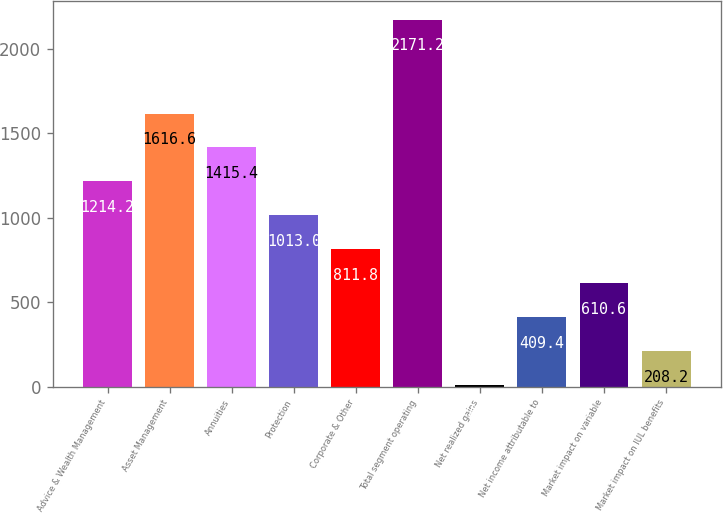<chart> <loc_0><loc_0><loc_500><loc_500><bar_chart><fcel>Advice & Wealth Management<fcel>Asset Management<fcel>Annuities<fcel>Protection<fcel>Corporate & Other<fcel>Total segment operating<fcel>Net realized gains<fcel>Net income attributable to<fcel>Market impact on variable<fcel>Market impact on IUL benefits<nl><fcel>1214.2<fcel>1616.6<fcel>1415.4<fcel>1013<fcel>811.8<fcel>2171.2<fcel>7<fcel>409.4<fcel>610.6<fcel>208.2<nl></chart> 